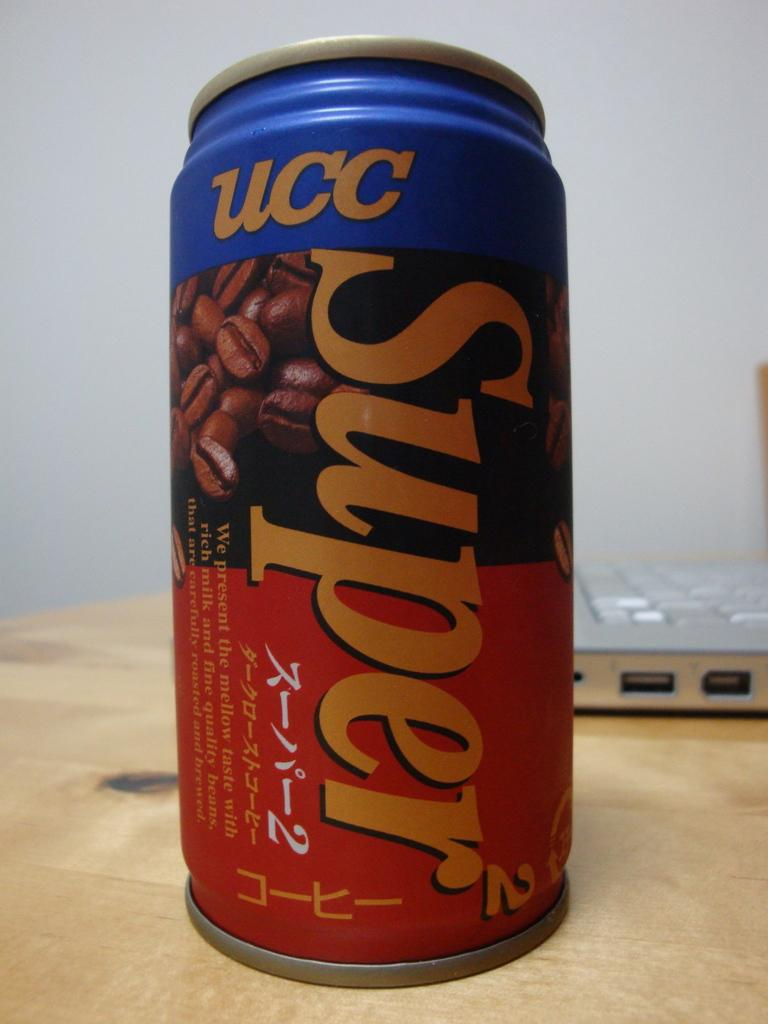<image>
Render a clear and concise summary of the photo. UCC Super drink in a tall can in front of a laptop 